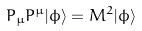Convert formula to latex. <formula><loc_0><loc_0><loc_500><loc_500>P _ { \mu } P ^ { \mu } | \phi \rangle = M ^ { 2 } | \phi \rangle</formula> 